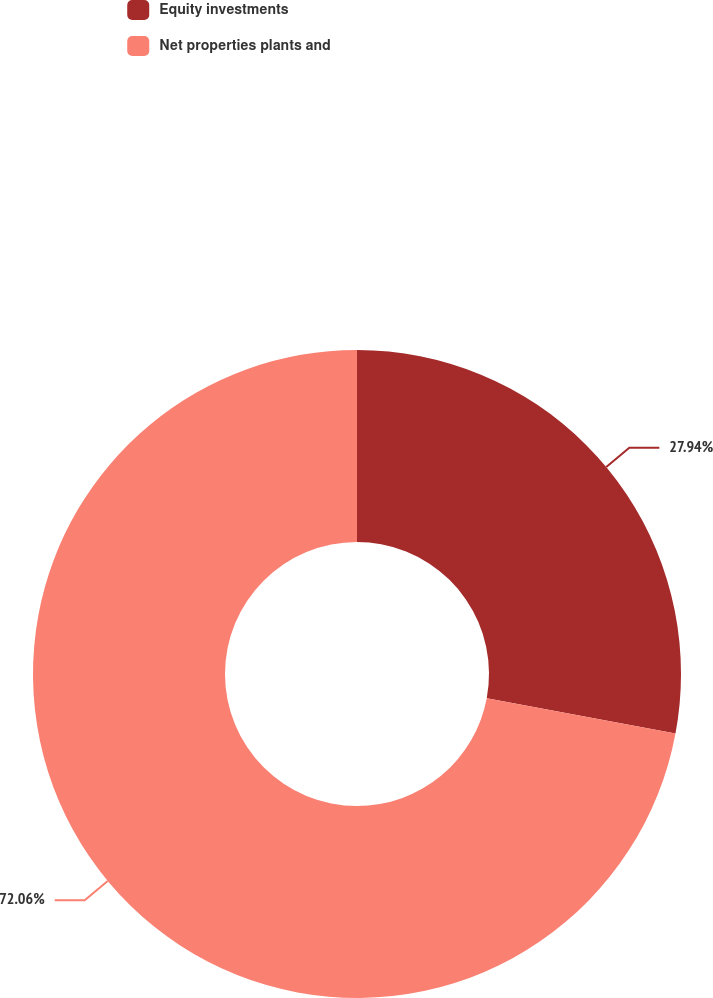Convert chart to OTSL. <chart><loc_0><loc_0><loc_500><loc_500><pie_chart><fcel>Equity investments<fcel>Net properties plants and<nl><fcel>27.94%<fcel>72.06%<nl></chart> 